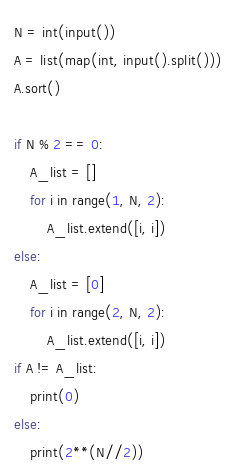<code> <loc_0><loc_0><loc_500><loc_500><_Python_>N = int(input())
A = list(map(int, input().split()))
A.sort()

if N % 2 == 0:
    A_list = []
    for i in range(1, N, 2):
        A_list.extend([i, i])
else:
    A_list = [0]
    for i in range(2, N, 2):
        A_list.extend([i, i])
if A != A_list:
    print(0)
else:
    print(2**(N//2))</code> 